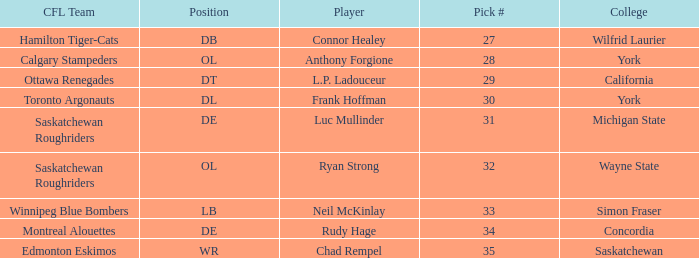What is the Pick # for the Edmonton Eskimos? 1.0. Help me parse the entirety of this table. {'header': ['CFL Team', 'Position', 'Player', 'Pick #', 'College'], 'rows': [['Hamilton Tiger-Cats', 'DB', 'Connor Healey', '27', 'Wilfrid Laurier'], ['Calgary Stampeders', 'OL', 'Anthony Forgione', '28', 'York'], ['Ottawa Renegades', 'DT', 'L.P. Ladouceur', '29', 'California'], ['Toronto Argonauts', 'DL', 'Frank Hoffman', '30', 'York'], ['Saskatchewan Roughriders', 'DE', 'Luc Mullinder', '31', 'Michigan State'], ['Saskatchewan Roughriders', 'OL', 'Ryan Strong', '32', 'Wayne State'], ['Winnipeg Blue Bombers', 'LB', 'Neil McKinlay', '33', 'Simon Fraser'], ['Montreal Alouettes', 'DE', 'Rudy Hage', '34', 'Concordia'], ['Edmonton Eskimos', 'WR', 'Chad Rempel', '35', 'Saskatchewan']]} 